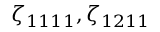Convert formula to latex. <formula><loc_0><loc_0><loc_500><loc_500>\zeta _ { 1 1 1 1 } , \zeta _ { 1 2 1 1 }</formula> 